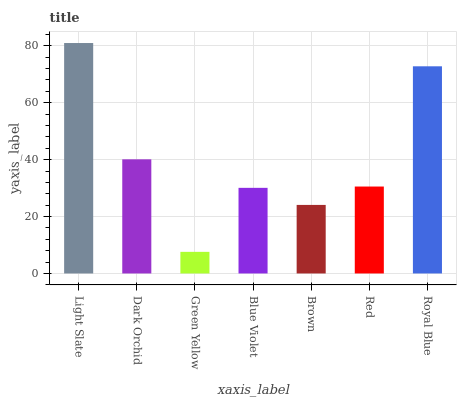Is Green Yellow the minimum?
Answer yes or no. Yes. Is Light Slate the maximum?
Answer yes or no. Yes. Is Dark Orchid the minimum?
Answer yes or no. No. Is Dark Orchid the maximum?
Answer yes or no. No. Is Light Slate greater than Dark Orchid?
Answer yes or no. Yes. Is Dark Orchid less than Light Slate?
Answer yes or no. Yes. Is Dark Orchid greater than Light Slate?
Answer yes or no. No. Is Light Slate less than Dark Orchid?
Answer yes or no. No. Is Red the high median?
Answer yes or no. Yes. Is Red the low median?
Answer yes or no. Yes. Is Light Slate the high median?
Answer yes or no. No. Is Blue Violet the low median?
Answer yes or no. No. 